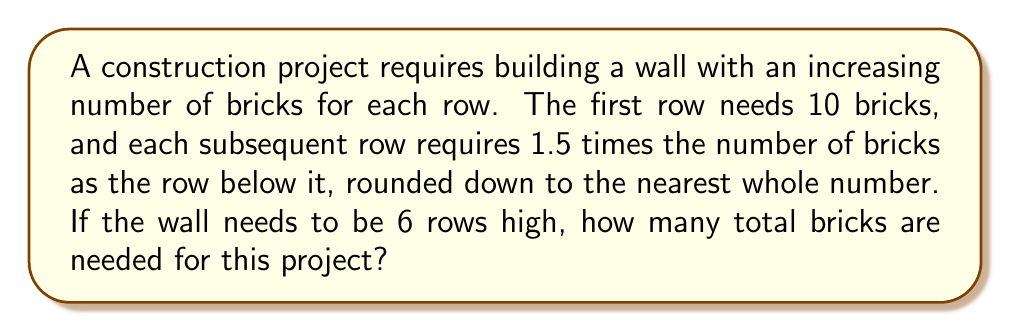What is the answer to this math problem? Let's approach this step-by-step:

1) We're dealing with a geometric sequence where each term is 1.5 times the previous term, rounded down.

2) Let's calculate the number of bricks for each row:
   Row 1 (bottom): $10$ bricks
   Row 2: $\lfloor 10 \times 1.5 \rfloor = 15$ bricks
   Row 3: $\lfloor 15 \times 1.5 \rfloor = 22$ bricks
   Row 4: $\lfloor 22 \times 1.5 \rfloor = 33$ bricks
   Row 5: $\lfloor 33 \times 1.5 \rfloor = 49$ bricks
   Row 6 (top): $\lfloor 49 \times 1.5 \rfloor = 73$ bricks

3) To find the total number of bricks, we sum all these values:

   $$ \text{Total bricks} = 10 + 15 + 22 + 33 + 49 + 73 = 202 $$

Thus, 202 bricks are needed for this wall construction project.
Answer: 202 bricks 